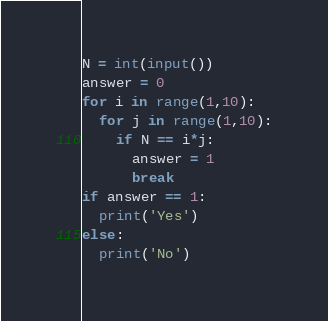<code> <loc_0><loc_0><loc_500><loc_500><_Python_>N = int(input())
answer = 0
for i in range(1,10):
  for j in range(1,10):
    if N == i*j:
      answer = 1
      break
if answer == 1:
  print('Yes')
else:
  print('No')</code> 